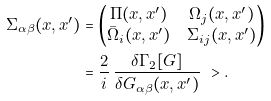Convert formula to latex. <formula><loc_0><loc_0><loc_500><loc_500>\Sigma _ { \alpha \beta } ( x , x ^ { \prime } ) & = \begin{pmatrix} \Pi ( x , x ^ { \prime } ) & \Omega _ { j } ( x , x ^ { \prime } ) \\ \bar { \Omega } _ { i } ( x , x ^ { \prime } ) & \Sigma _ { i j } ( x , x ^ { \prime } ) \end{pmatrix} \\ & = \frac { 2 } { i } \, \frac { \delta \Gamma _ { 2 } [ G ] } { \delta G _ { \alpha \beta } ( x , x ^ { \prime } ) } \ > .</formula> 